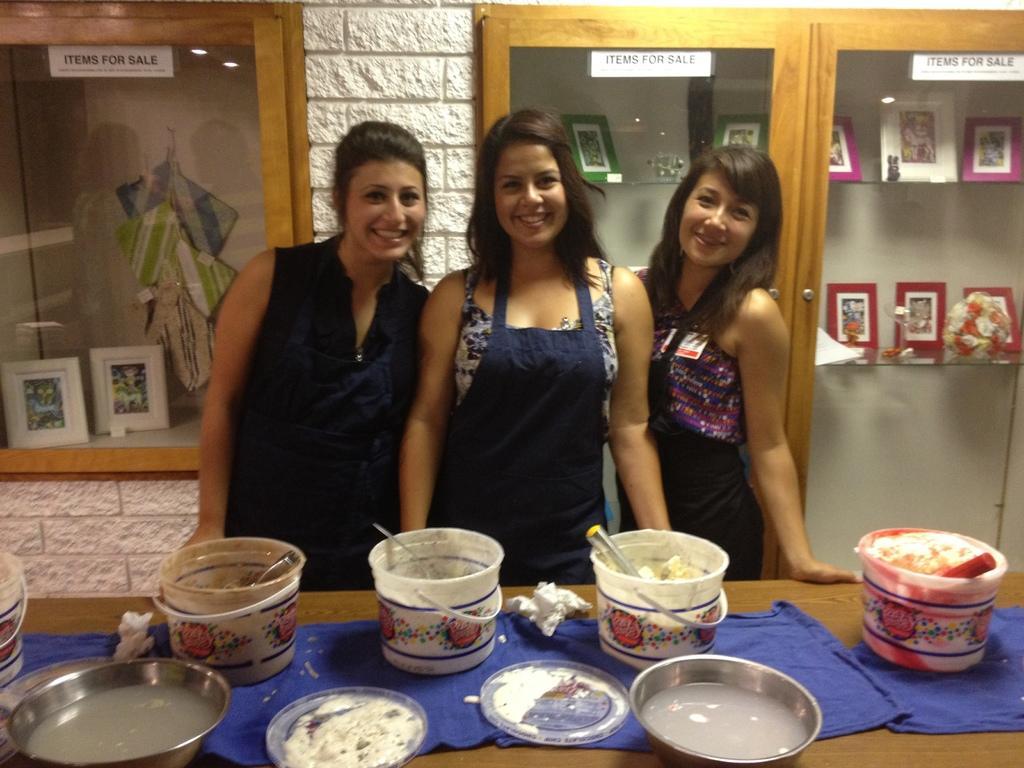Please provide a concise description of this image. In the foreground of the picture there is a desk, on the desk there are the buckets, bowls, water, tissues, ice creams, mat. In the center of the picture there are three women standing. On the left there is a cupboard, in the cupboard there are frames. On the right there is a cupboard, on the cupboard there are frames. At the top there is a brick wall. 